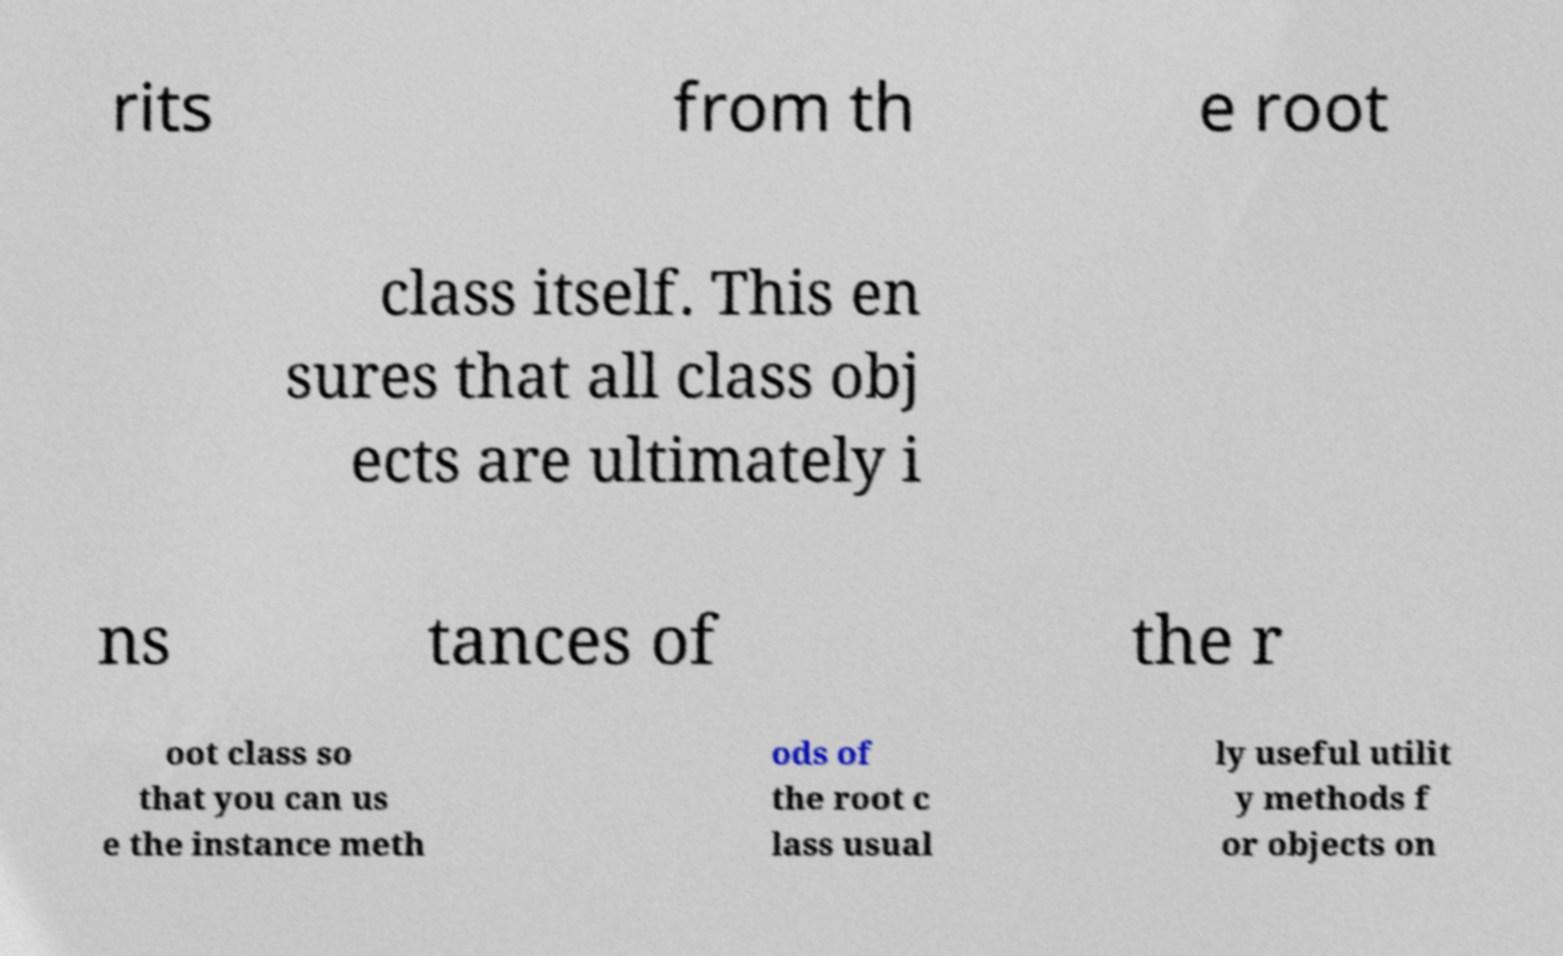I need the written content from this picture converted into text. Can you do that? rits from th e root class itself. This en sures that all class obj ects are ultimately i ns tances of the r oot class so that you can us e the instance meth ods of the root c lass usual ly useful utilit y methods f or objects on 